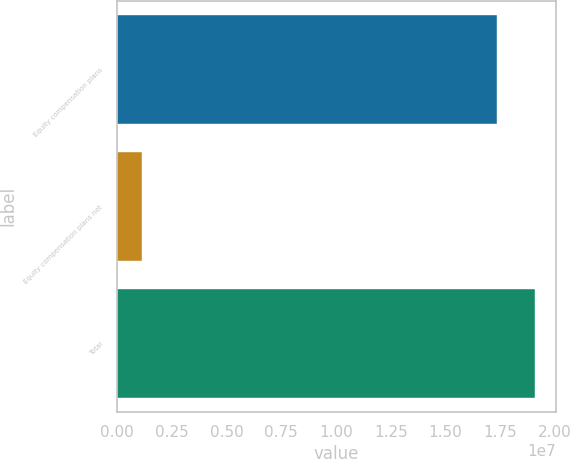Convert chart to OTSL. <chart><loc_0><loc_0><loc_500><loc_500><bar_chart><fcel>Equity compensation plans<fcel>Equity compensation plans not<fcel>Total<nl><fcel>1.73495e+07<fcel>1.14768e+06<fcel>1.90845e+07<nl></chart> 